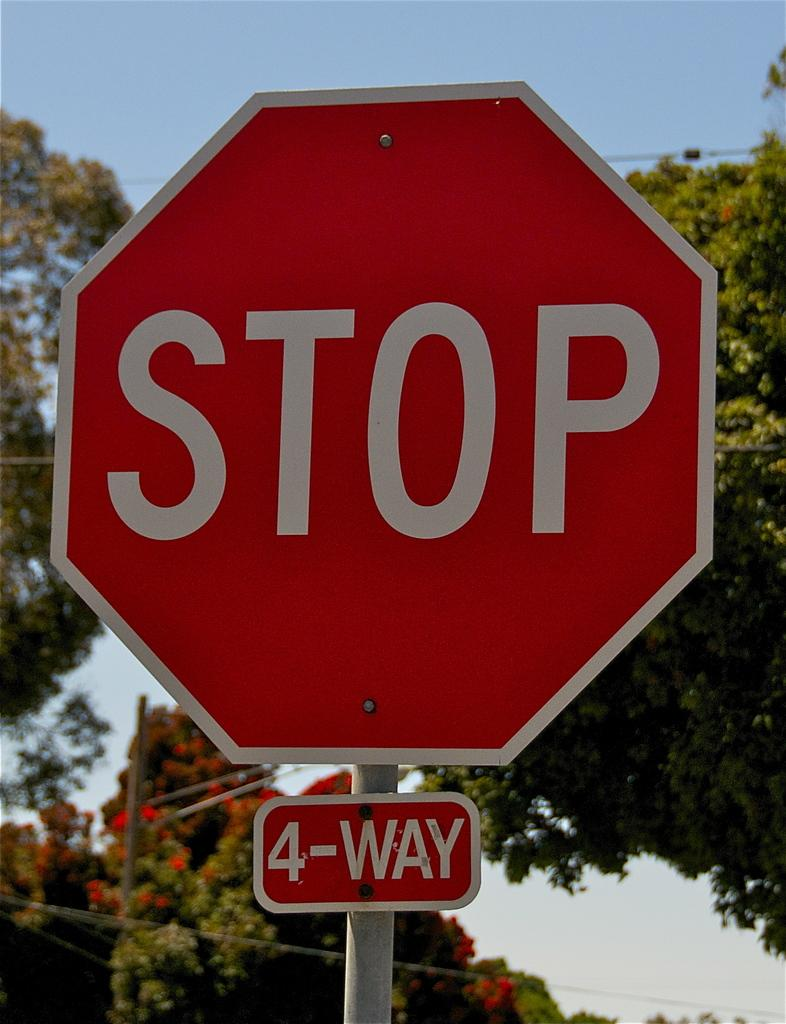<image>
Summarize the visual content of the image. a 4-way stop sign in outdoor street corner 